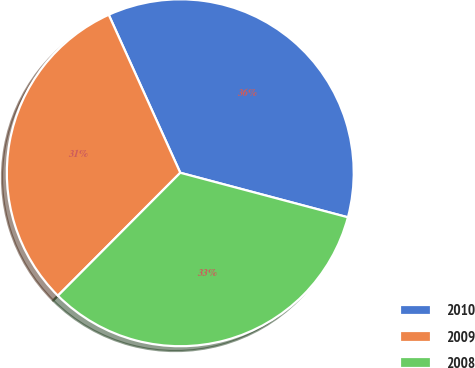Convert chart to OTSL. <chart><loc_0><loc_0><loc_500><loc_500><pie_chart><fcel>2010<fcel>2009<fcel>2008<nl><fcel>35.9%<fcel>30.77%<fcel>33.33%<nl></chart> 